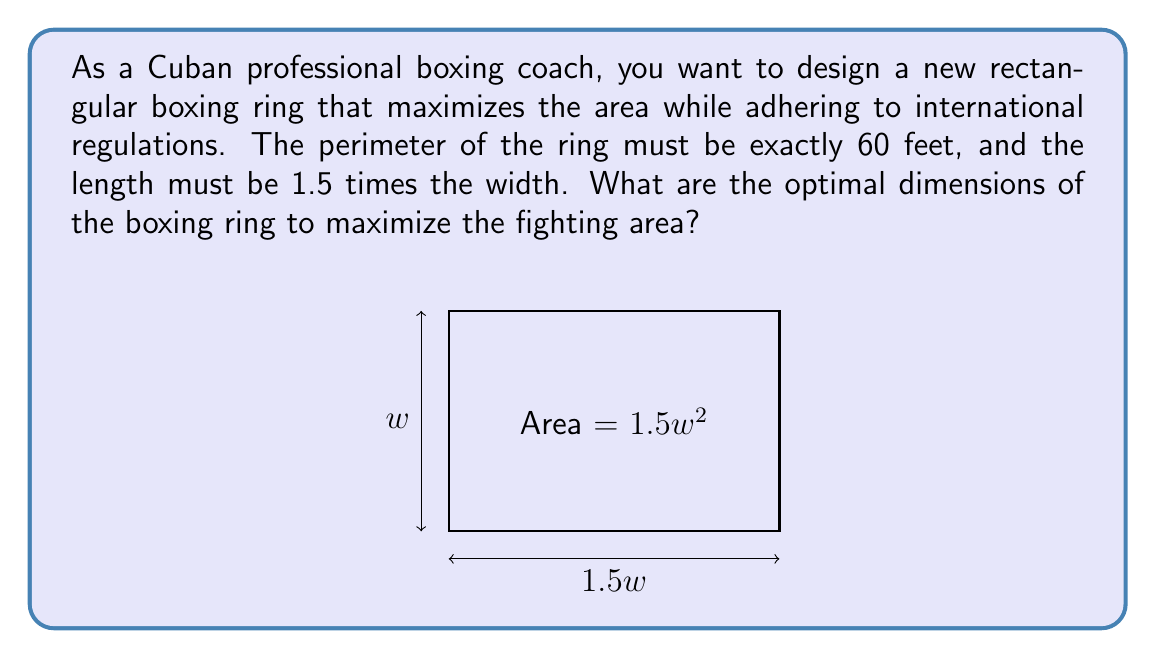Help me with this question. Let's approach this step-by-step using constrained optimization techniques:

1) Let $w$ be the width of the ring and $1.5w$ be the length.

2) The area of the ring is given by:
   $A = w \cdot 1.5w = 1.5w^2$

3) The perimeter constraint is:
   $2w + 2(1.5w) = 60$
   $2w + 3w = 60$
   $5w = 60$

4) Solving for $w$:
   $w = 60/5 = 12$ feet

5) The length is therefore:
   $1.5w = 1.5 \cdot 12 = 18$ feet

6) To verify this is indeed a maximum, we could use the second derivative test or consider that the area function $A = 1.5w^2$ is always concave up, so any critical point will be a global minimum on the open interval $(0,\infty)$.

7) The maximum area is:
   $A = 1.5w^2 = 1.5 \cdot 12^2 = 216$ square feet
Answer: Width: 12 feet, Length: 18 feet 